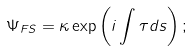Convert formula to latex. <formula><loc_0><loc_0><loc_500><loc_500>\Psi _ { F S } = \kappa \exp \left ( i \int \tau d s \right ) ;</formula> 